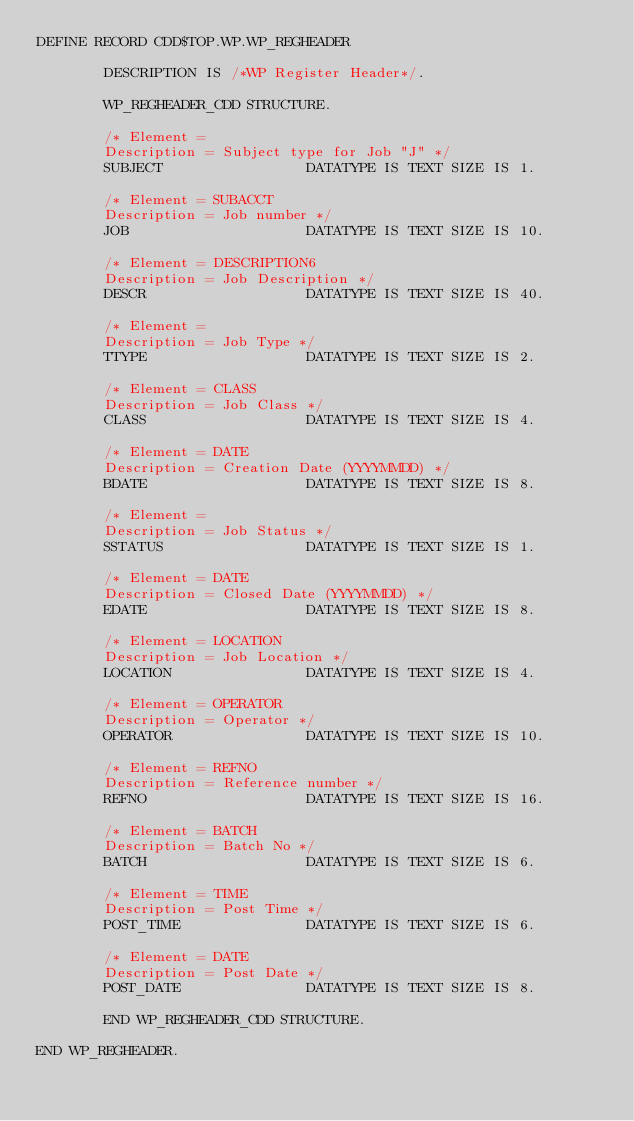Convert code to text. <code><loc_0><loc_0><loc_500><loc_500><_SQL_>DEFINE RECORD CDD$TOP.WP.WP_REGHEADER

        DESCRIPTION IS /*WP Register Header*/.

        WP_REGHEADER_CDD STRUCTURE.

        /* Element =
        Description = Subject type for Job "J" */
        SUBJECT                 DATATYPE IS TEXT SIZE IS 1.

        /* Element = SUBACCT
        Description = Job number */
        JOB                     DATATYPE IS TEXT SIZE IS 10.

        /* Element = DESCRIPTION6
        Description = Job Description */
        DESCR                   DATATYPE IS TEXT SIZE IS 40.

        /* Element =
        Description = Job Type */
        TTYPE                   DATATYPE IS TEXT SIZE IS 2.

        /* Element = CLASS
        Description = Job Class */
        CLASS                   DATATYPE IS TEXT SIZE IS 4.

        /* Element = DATE
        Description = Creation Date (YYYYMMDD) */
        BDATE                   DATATYPE IS TEXT SIZE IS 8.

        /* Element =
        Description = Job Status */
        SSTATUS                 DATATYPE IS TEXT SIZE IS 1.

        /* Element = DATE
        Description = Closed Date (YYYYMMDD) */
        EDATE                   DATATYPE IS TEXT SIZE IS 8.

        /* Element = LOCATION
        Description = Job Location */
        LOCATION                DATATYPE IS TEXT SIZE IS 4.

        /* Element = OPERATOR
        Description = Operator */
        OPERATOR                DATATYPE IS TEXT SIZE IS 10.

        /* Element = REFNO
        Description = Reference number */
        REFNO                   DATATYPE IS TEXT SIZE IS 16.

        /* Element = BATCH
        Description = Batch No */
        BATCH                   DATATYPE IS TEXT SIZE IS 6.

        /* Element = TIME
        Description = Post Time */
        POST_TIME               DATATYPE IS TEXT SIZE IS 6.

        /* Element = DATE
        Description = Post Date */
        POST_DATE               DATATYPE IS TEXT SIZE IS 8.

        END WP_REGHEADER_CDD STRUCTURE.

END WP_REGHEADER.
</code> 